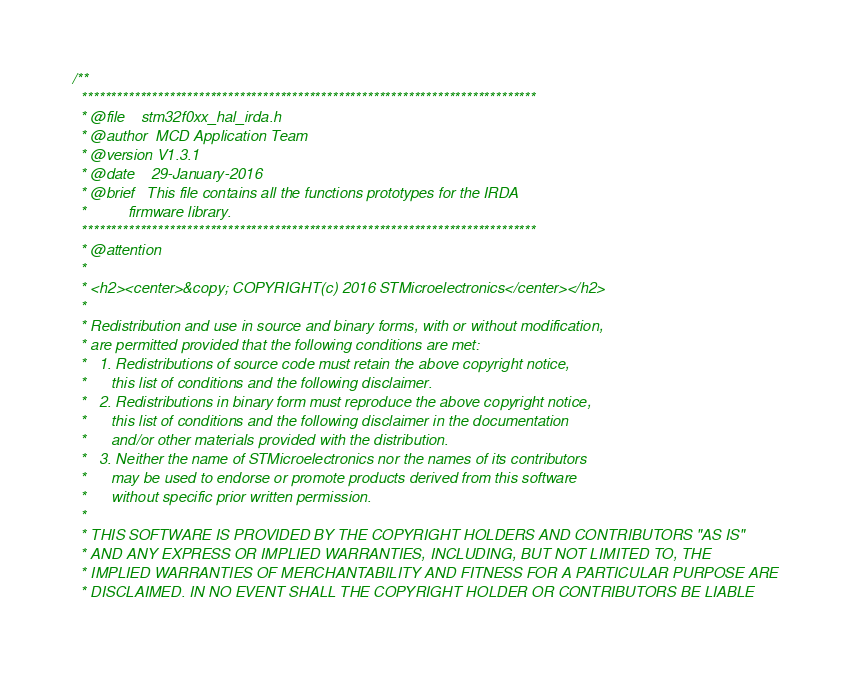<code> <loc_0><loc_0><loc_500><loc_500><_C_>/**
  ******************************************************************************
  * @file    stm32f0xx_hal_irda.h
  * @author  MCD Application Team
  * @version V1.3.1
  * @date    29-January-2016
  * @brief   This file contains all the functions prototypes for the IRDA 
  *          firmware library.
  ******************************************************************************
  * @attention
  *
  * <h2><center>&copy; COPYRIGHT(c) 2016 STMicroelectronics</center></h2>
  *
  * Redistribution and use in source and binary forms, with or without modification,
  * are permitted provided that the following conditions are met:
  *   1. Redistributions of source code must retain the above copyright notice,
  *      this list of conditions and the following disclaimer.
  *   2. Redistributions in binary form must reproduce the above copyright notice,
  *      this list of conditions and the following disclaimer in the documentation
  *      and/or other materials provided with the distribution.
  *   3. Neither the name of STMicroelectronics nor the names of its contributors
  *      may be used to endorse or promote products derived from this software
  *      without specific prior written permission.
  *
  * THIS SOFTWARE IS PROVIDED BY THE COPYRIGHT HOLDERS AND CONTRIBUTORS "AS IS"
  * AND ANY EXPRESS OR IMPLIED WARRANTIES, INCLUDING, BUT NOT LIMITED TO, THE
  * IMPLIED WARRANTIES OF MERCHANTABILITY AND FITNESS FOR A PARTICULAR PURPOSE ARE
  * DISCLAIMED. IN NO EVENT SHALL THE COPYRIGHT HOLDER OR CONTRIBUTORS BE LIABLE</code> 